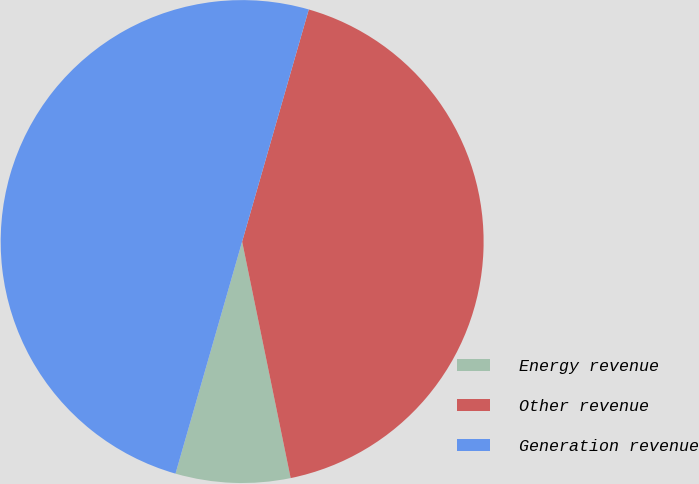<chart> <loc_0><loc_0><loc_500><loc_500><pie_chart><fcel>Energy revenue<fcel>Other revenue<fcel>Generation revenue<nl><fcel>7.67%<fcel>42.33%<fcel>50.0%<nl></chart> 